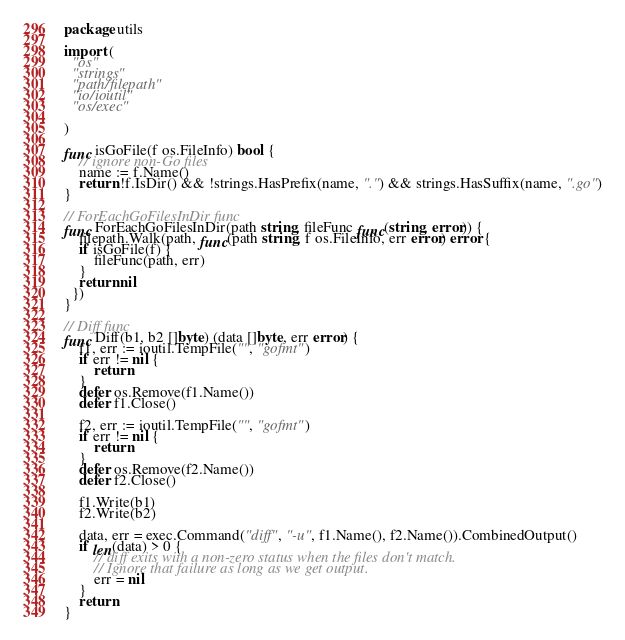<code> <loc_0><loc_0><loc_500><loc_500><_Go_>package utils

import (
  "os"
  "strings"
  "path/filepath"
  "io/ioutil"
  "os/exec"

)

func isGoFile(f os.FileInfo) bool {
	// ignore non-Go files
	name := f.Name()
	return !f.IsDir() && !strings.HasPrefix(name, ".") && strings.HasSuffix(name, ".go")
}

// ForEachGoFilesInDir func
func ForEachGoFilesInDir(path string, fileFunc func(string, error)) {
	filepath.Walk(path, func(path string, f os.FileInfo, err error) error {
    if isGoFile(f) {
  		fileFunc(path, err)
  	}
  	return nil
  })
}

// Diff func
func Diff(b1, b2 []byte) (data []byte, err error) {
	f1, err := ioutil.TempFile("", "gofmt")
	if err != nil {
		return
	}
	defer os.Remove(f1.Name())
	defer f1.Close()

	f2, err := ioutil.TempFile("", "gofmt")
	if err != nil {
		return
	}
	defer os.Remove(f2.Name())
	defer f2.Close()

	f1.Write(b1)
	f2.Write(b2)

	data, err = exec.Command("diff", "-u", f1.Name(), f2.Name()).CombinedOutput()
	if len(data) > 0 {
		// diff exits with a non-zero status when the files don't match.
		// Ignore that failure as long as we get output.
		err = nil
	}
	return
}
</code> 